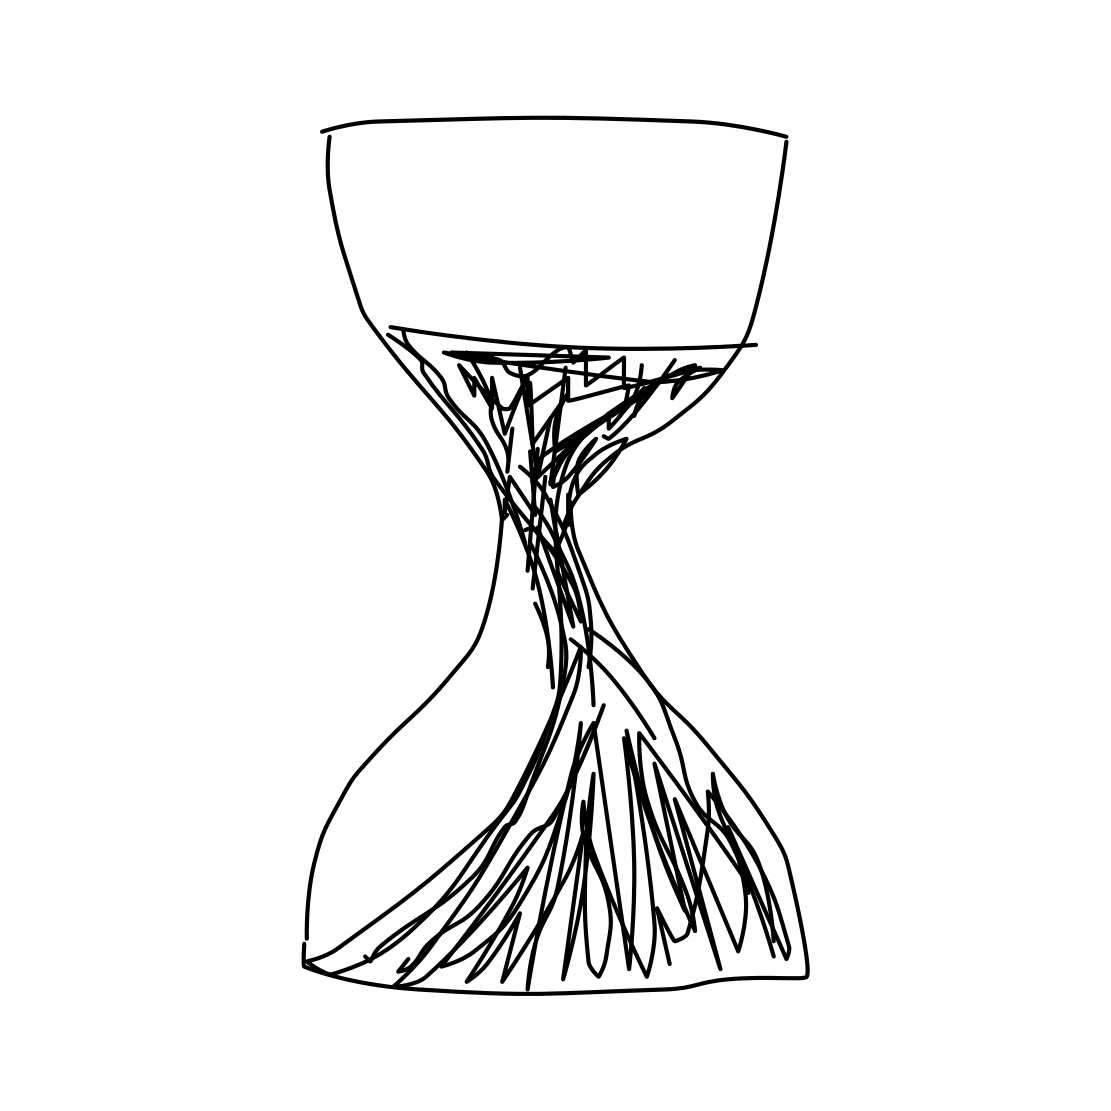Is this a hourglass in the image? Yes, the image depicts a stylized drawing of a hourglass. It portrays the classic design where the upper and lower bulbs are symmetric with sand flowing through a narrow channel in the middle, capturing the essence of time passing. 